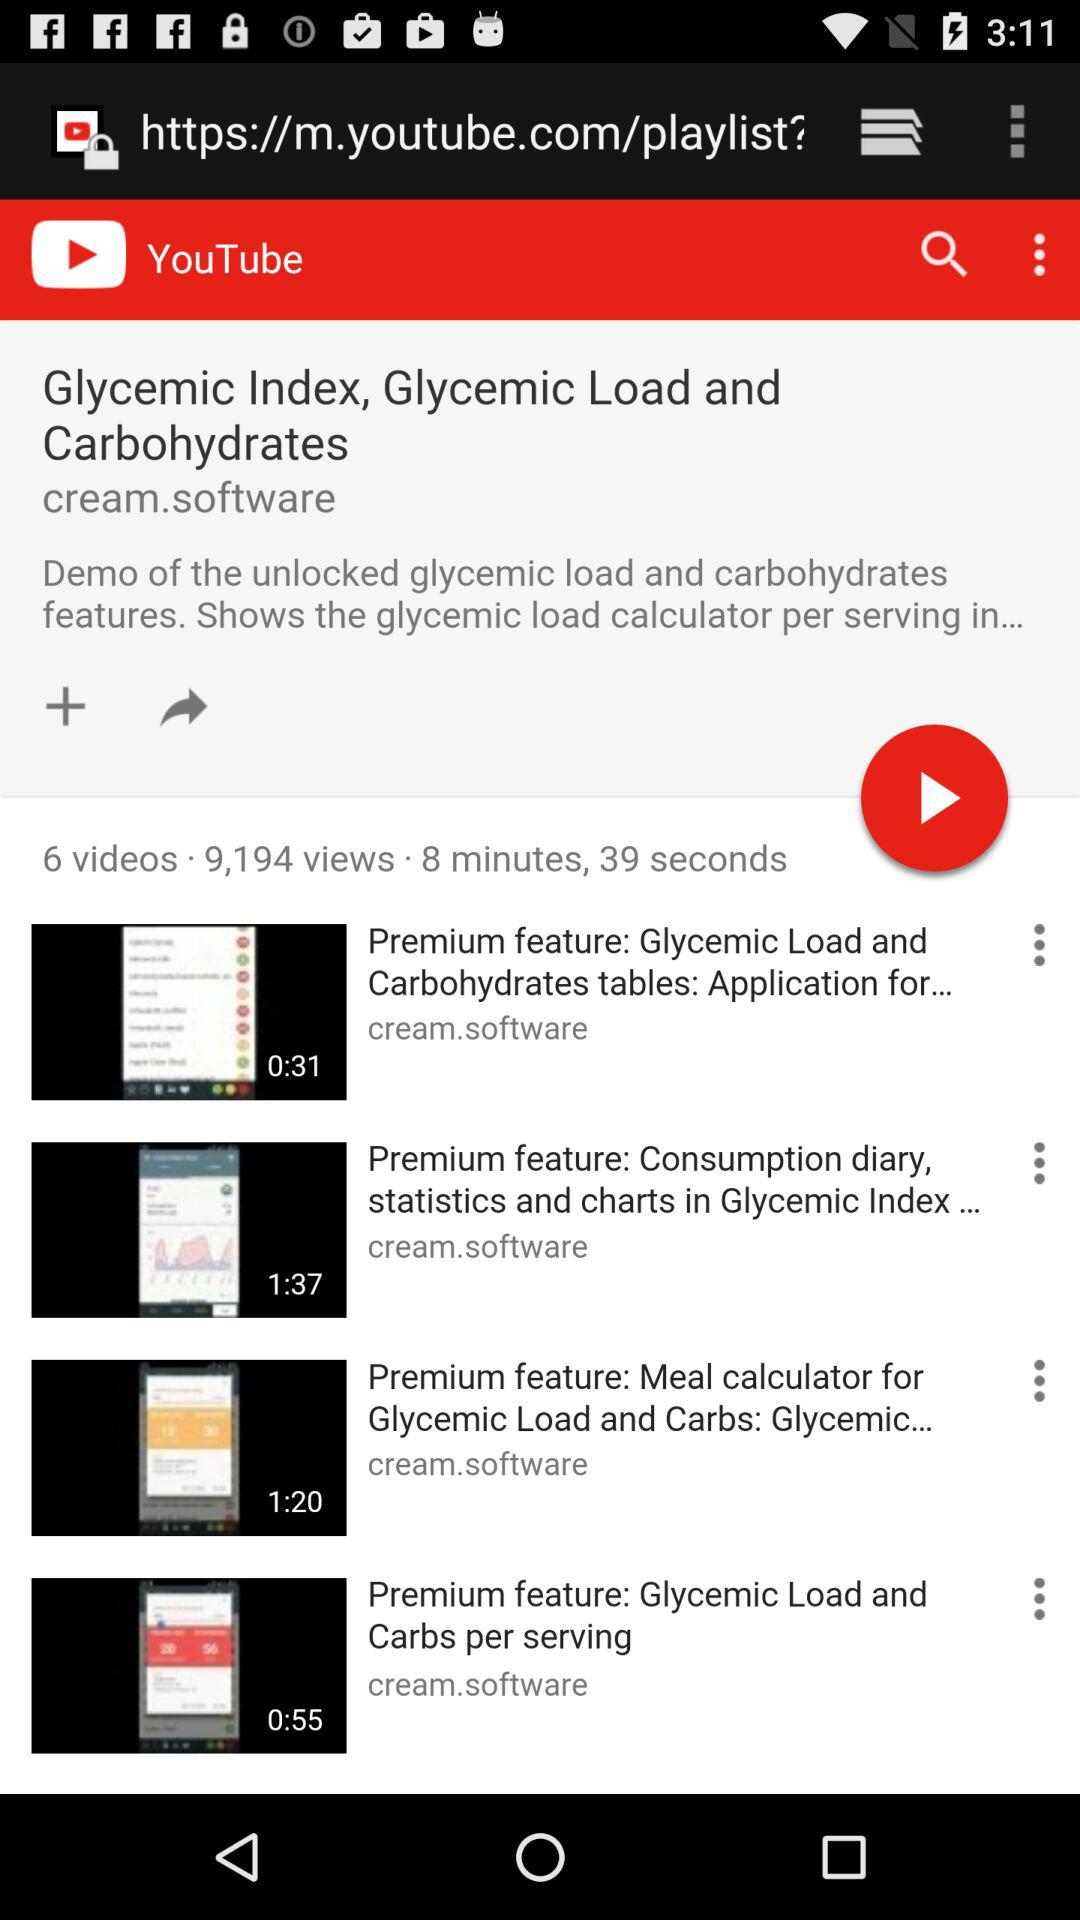How many views are there of the playlist? There are 9,194 views of the playlist. 